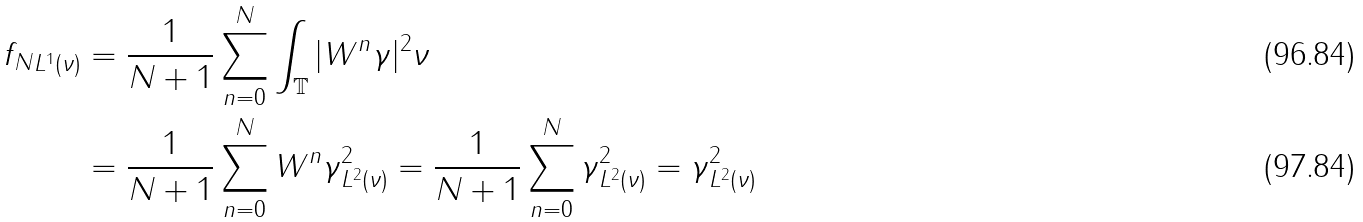<formula> <loc_0><loc_0><loc_500><loc_500>\| f _ { N } \| _ { L ^ { 1 } ( \nu ) } & = \frac { 1 } { N + 1 } \sum _ { n = 0 } ^ { N } \int _ { \mathbb { T } } | W ^ { n } \gamma | ^ { 2 } \nu \\ & = \frac { 1 } { N + 1 } \sum _ { n = 0 } ^ { N } \| W ^ { n } \gamma \| _ { L ^ { 2 } ( \nu ) } ^ { 2 } = \frac { 1 } { N + 1 } \sum _ { n = 0 } ^ { N } \| \gamma \| _ { L ^ { 2 } ( \nu ) } ^ { 2 } = \| \gamma \| _ { L ^ { 2 } ( \nu ) } ^ { 2 }</formula> 